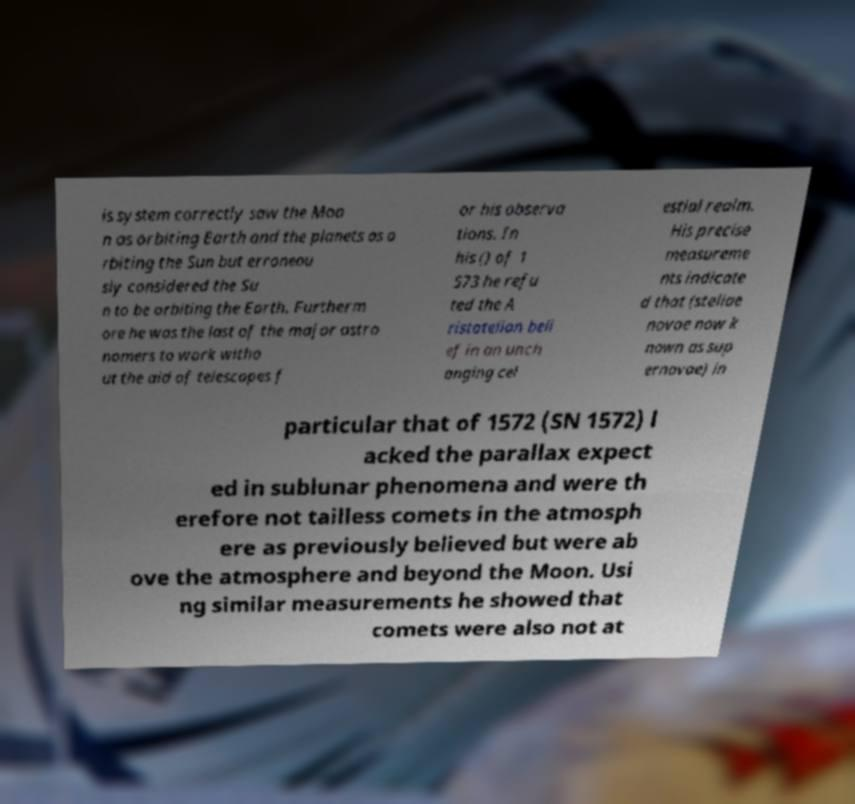I need the written content from this picture converted into text. Can you do that? is system correctly saw the Moo n as orbiting Earth and the planets as o rbiting the Sun but erroneou sly considered the Su n to be orbiting the Earth. Furtherm ore he was the last of the major astro nomers to work witho ut the aid of telescopes f or his observa tions. In his () of 1 573 he refu ted the A ristotelian beli ef in an unch anging cel estial realm. His precise measureme nts indicate d that (stellae novae now k nown as sup ernovae) in particular that of 1572 (SN 1572) l acked the parallax expect ed in sublunar phenomena and were th erefore not tailless comets in the atmosph ere as previously believed but were ab ove the atmosphere and beyond the Moon. Usi ng similar measurements he showed that comets were also not at 